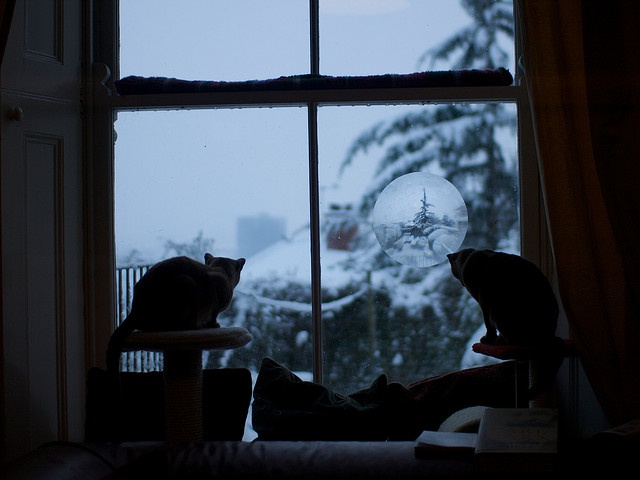Describe the objects in this image and their specific colors. I can see couch in black and blue tones, cat in black, blue, and gray tones, cat in black, navy, gray, and blue tones, and book in black tones in this image. 